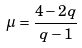Convert formula to latex. <formula><loc_0><loc_0><loc_500><loc_500>\mu = \frac { 4 - 2 q } { q - 1 }</formula> 